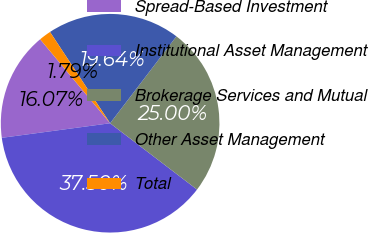<chart> <loc_0><loc_0><loc_500><loc_500><pie_chart><fcel>Spread-Based Investment<fcel>Institutional Asset Management<fcel>Brokerage Services and Mutual<fcel>Other Asset Management<fcel>Total<nl><fcel>16.07%<fcel>37.5%<fcel>25.0%<fcel>19.64%<fcel>1.79%<nl></chart> 